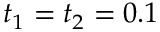Convert formula to latex. <formula><loc_0><loc_0><loc_500><loc_500>t _ { 1 } = t _ { 2 } = 0 . 1</formula> 